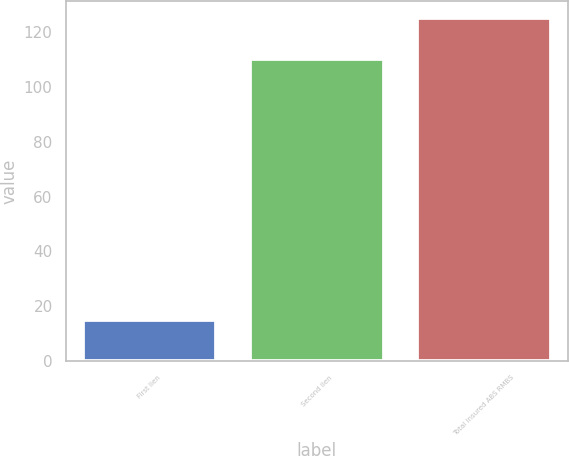<chart> <loc_0><loc_0><loc_500><loc_500><bar_chart><fcel>First lien<fcel>Second lien<fcel>Total insured ABS RMBS<nl><fcel>15<fcel>110<fcel>125<nl></chart> 